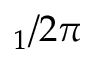<formula> <loc_0><loc_0><loc_500><loc_500>_ { 1 } / 2 \pi</formula> 